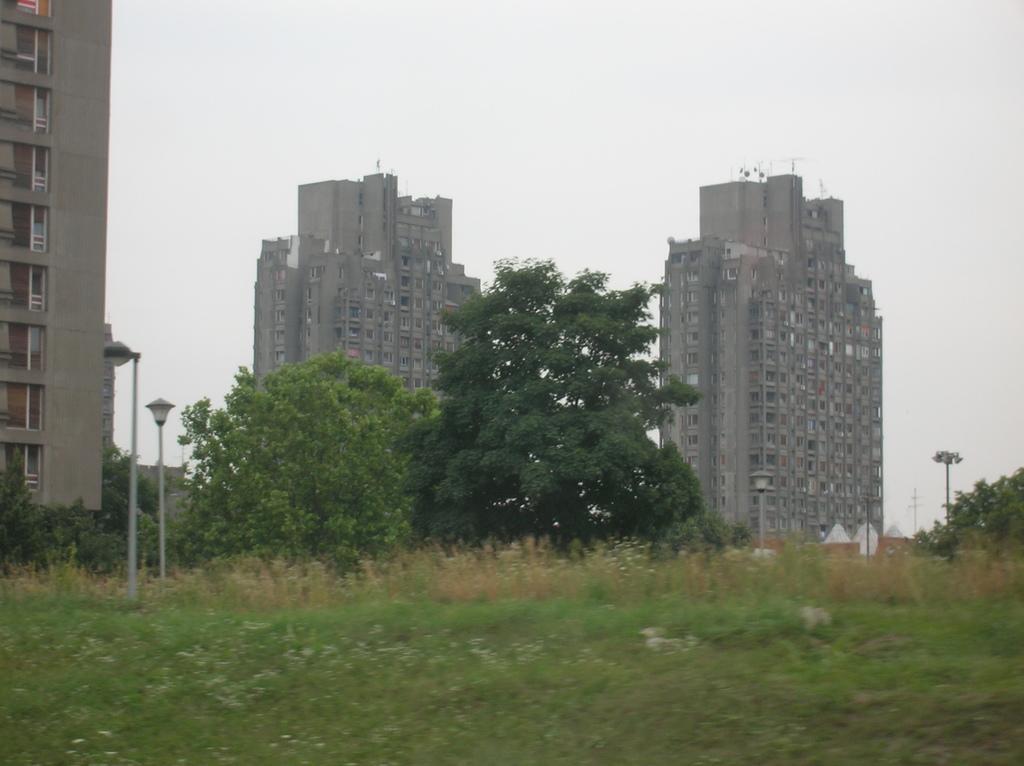Can you describe this image briefly? This picture is clicked outside the city. In the foreground we can see the green grass and the plants. In the center we can see the buildings, trees and lights attached to the poles and there is a sky. 